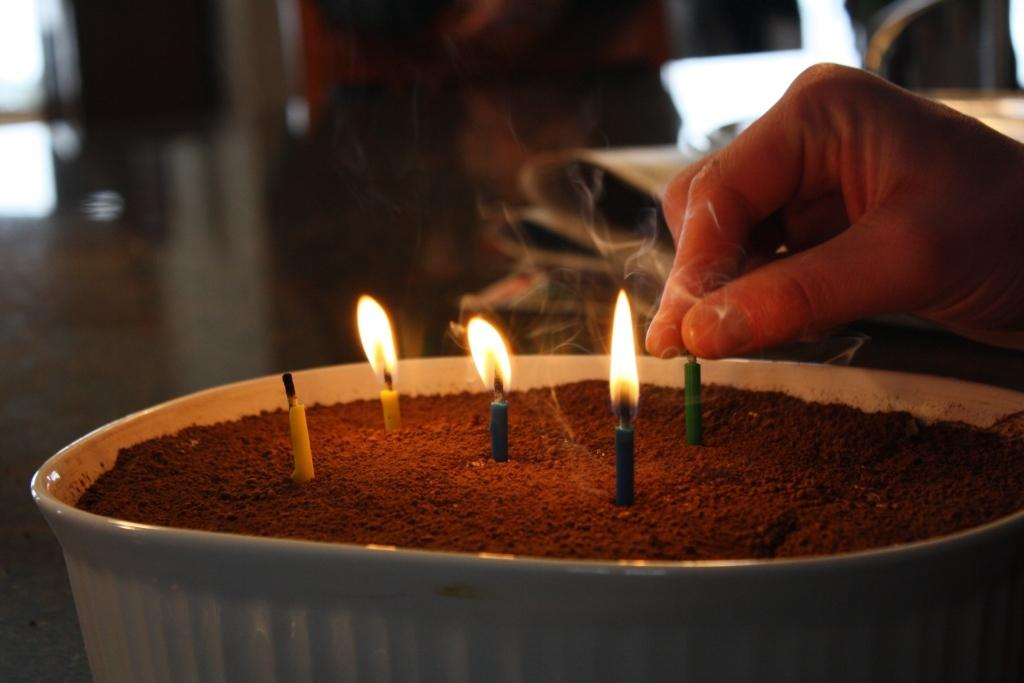What objects can be seen in the image? There are candles and a bowl of sand in the image. What is the hand of a person doing in the image? The hand of a person is on the right side of the image, but it is not clear what it is doing. How would you describe the background of the image? The background of the image is blurred. What type of zinc is being used to create the candles in the image? There is no information about the type of zinc used in the candles, and candles are typically made from wax, not zinc. 